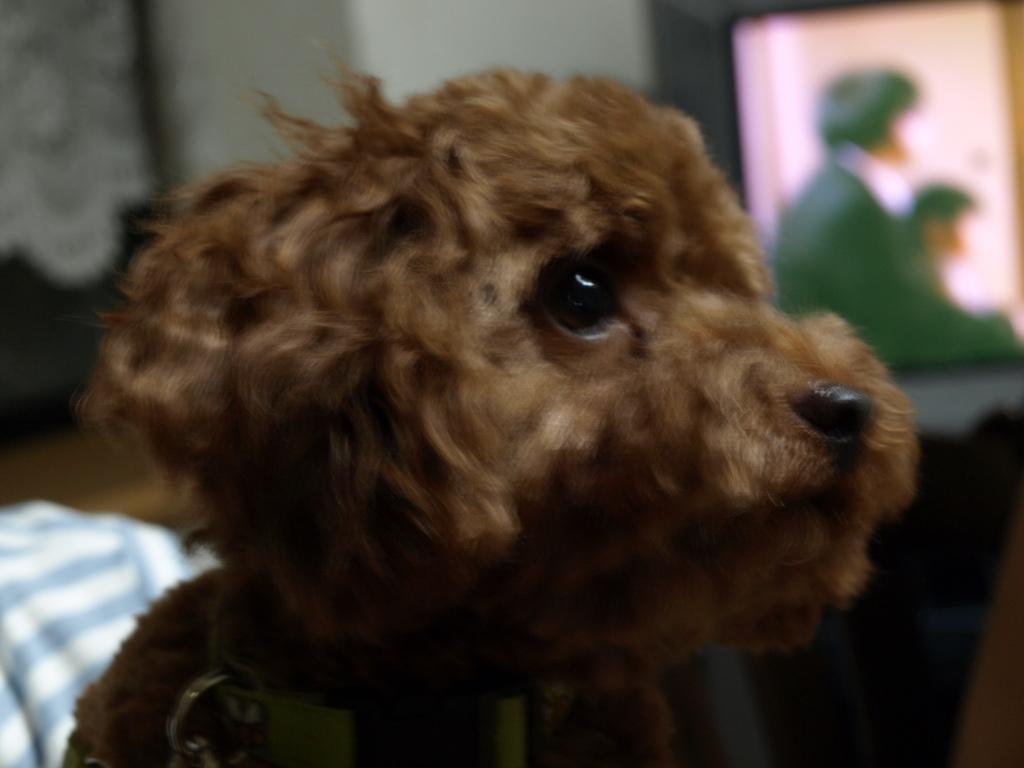In one or two sentences, can you explain what this image depicts? In this image we can see a dog with blurry background. 